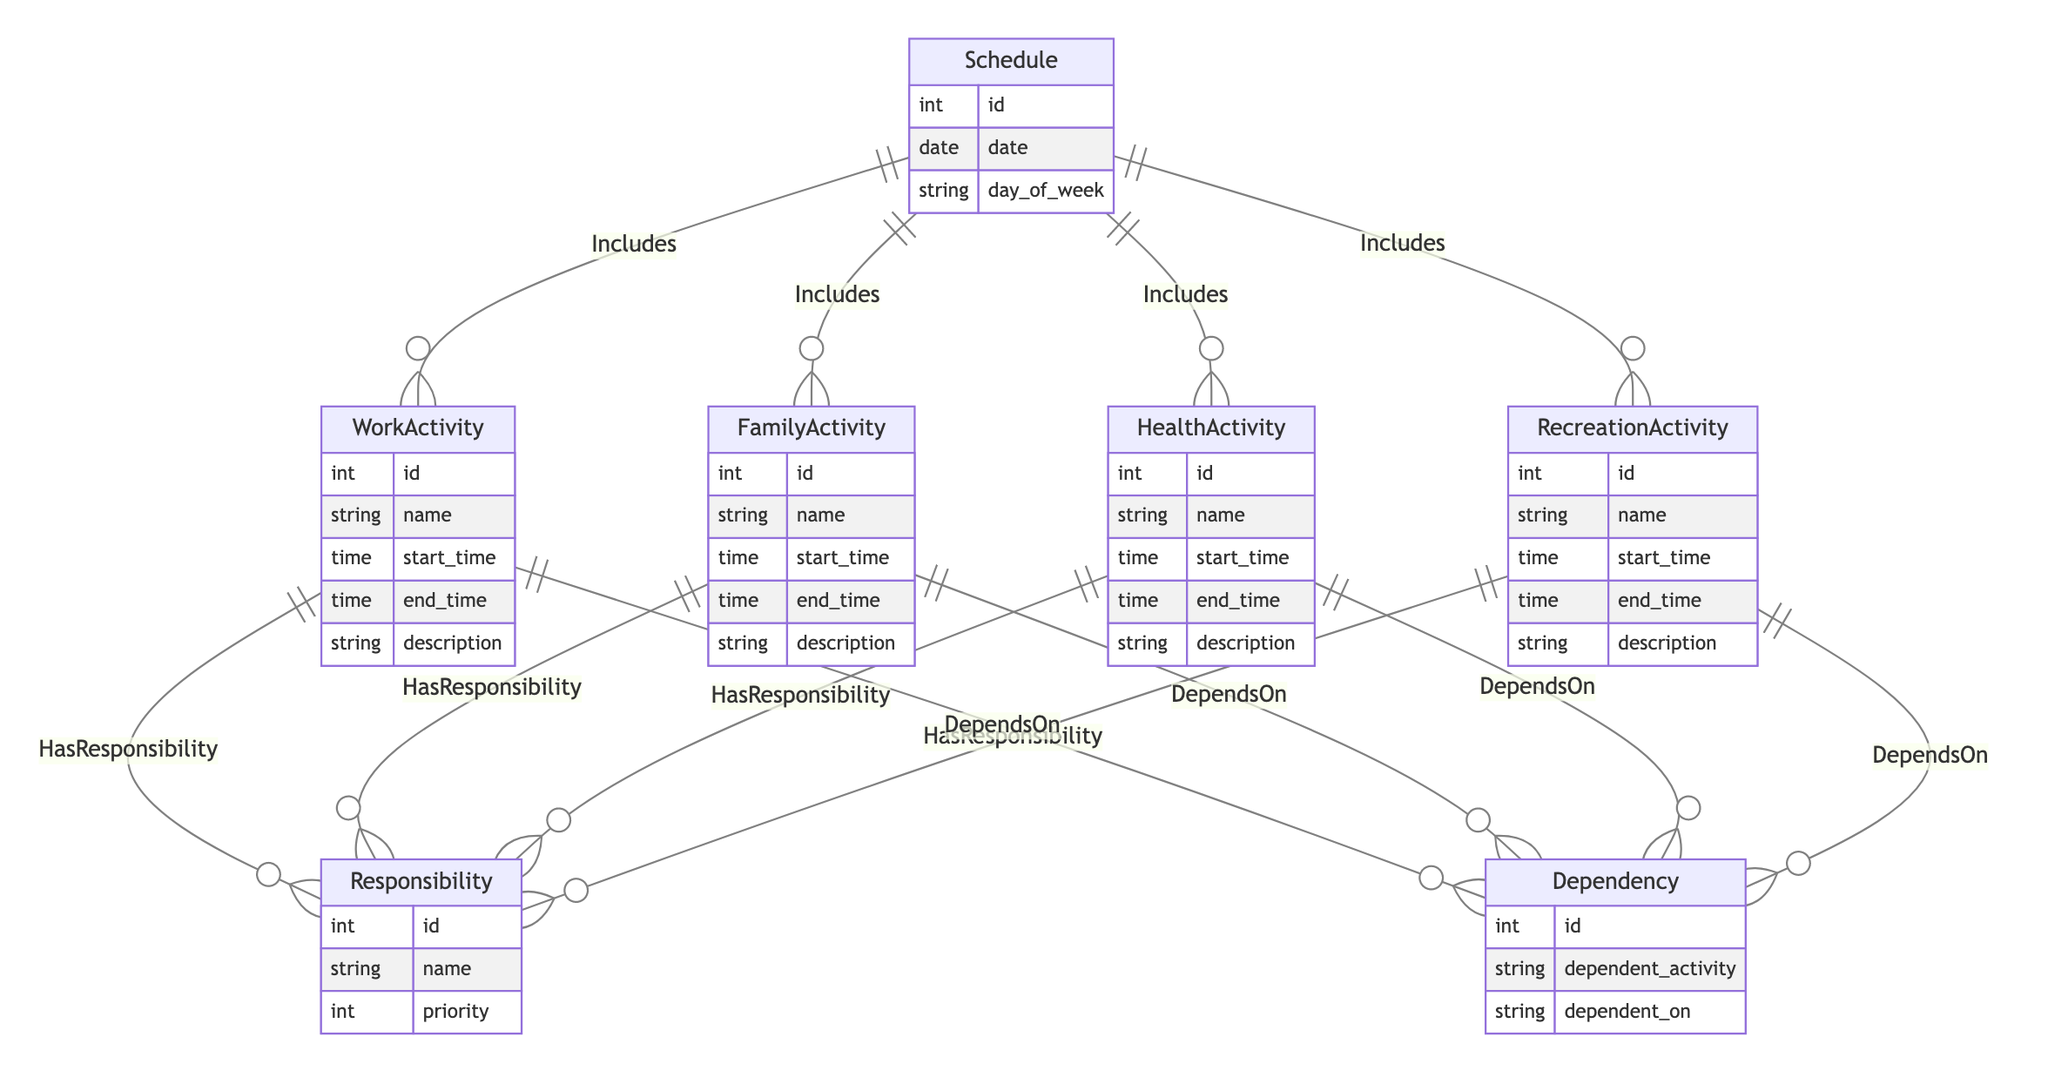What is the primary entity represented in the diagram? The primary entity in the diagram is "Schedule," as it is the central component that connects to various activities and includes their attributes.
Answer: Schedule How many types of activities are included in the schedule? There are four types of activities represented: WorkActivity, FamilyActivity, HealthActivity, and RecreationActivity. Each of these activities is connected to the Schedule entity, indicating they are included in it.
Answer: Four What is the relationship type between Schedule and WorkActivity? The relationship between Schedule and WorkActivity is "Includes," which indicates that a schedule can have multiple work activities associated with it.
Answer: Includes How many attributes does the HealthActivity entity have? The HealthActivity entity has five attributes: id, name, start_time, end_time, and description. This can be counted directly from the entity’s declaration in the diagram.
Answer: Five Which entity has a relationship with Responsibility? All activity entities—WorkActivity, FamilyActivity, HealthActivity, and RecreationActivity—have a relationship with Responsibility through the "HasResponsibility" relationship, indicating that each type of activity can have associated responsibilities.
Answer: All activities What is the maximum number of dependencies a single WorkActivity can have? A single WorkActivity can have many dependencies, as indicated by the "M:1" relationship type in the "DependsOn" relationship, meaning multiple dependencies can point to a single work activity.
Answer: Many Which activity type is associated with the highest priority based on the relationships? The priority associated with each type of activity cannot be determined directly from the diagram unless specific responsibility entries are provided. However, the diagram architecture allows for various prioritizations based on the responsibilities that can be linked to different activities.
Answer: Cannot determine How many entities in the diagram are linked to the Dependency entity? There are four entities linked to the Dependency entity: WorkActivity, FamilyActivity, HealthActivity, and RecreationActivity. Each of these activities can depend on a different factor, creating multiple connections to Dependency.
Answer: Four What does the "DependsOn" relationship signify in the context of the diagram? The "DependsOn" relationship signifies that particular activities depend on other activities to be completed or fulfilled. This creates a hierarchy of activity scheduling based on dependencies defined within the diagram.
Answer: Dependency 